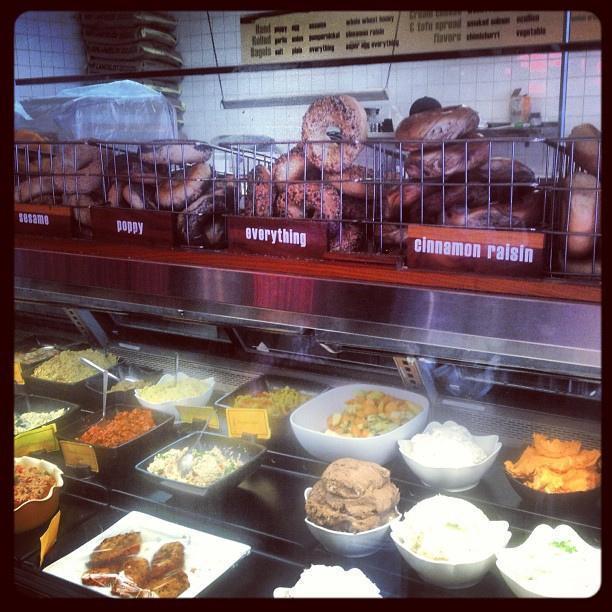How many bowls are visible?
Give a very brief answer. 9. 